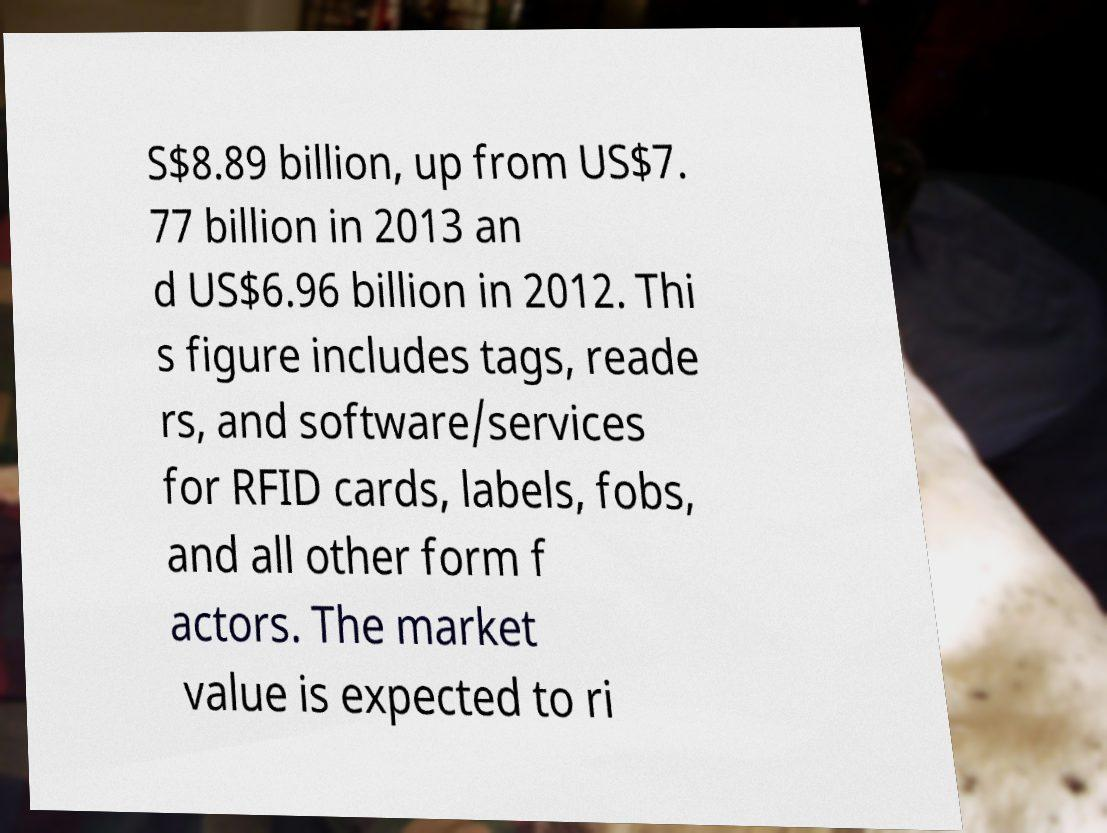Please read and relay the text visible in this image. What does it say? S$8.89 billion, up from US$7. 77 billion in 2013 an d US$6.96 billion in 2012. Thi s figure includes tags, reade rs, and software/services for RFID cards, labels, fobs, and all other form f actors. The market value is expected to ri 